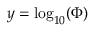Convert formula to latex. <formula><loc_0><loc_0><loc_500><loc_500>y = \log _ { 1 0 } ( \Phi )</formula> 